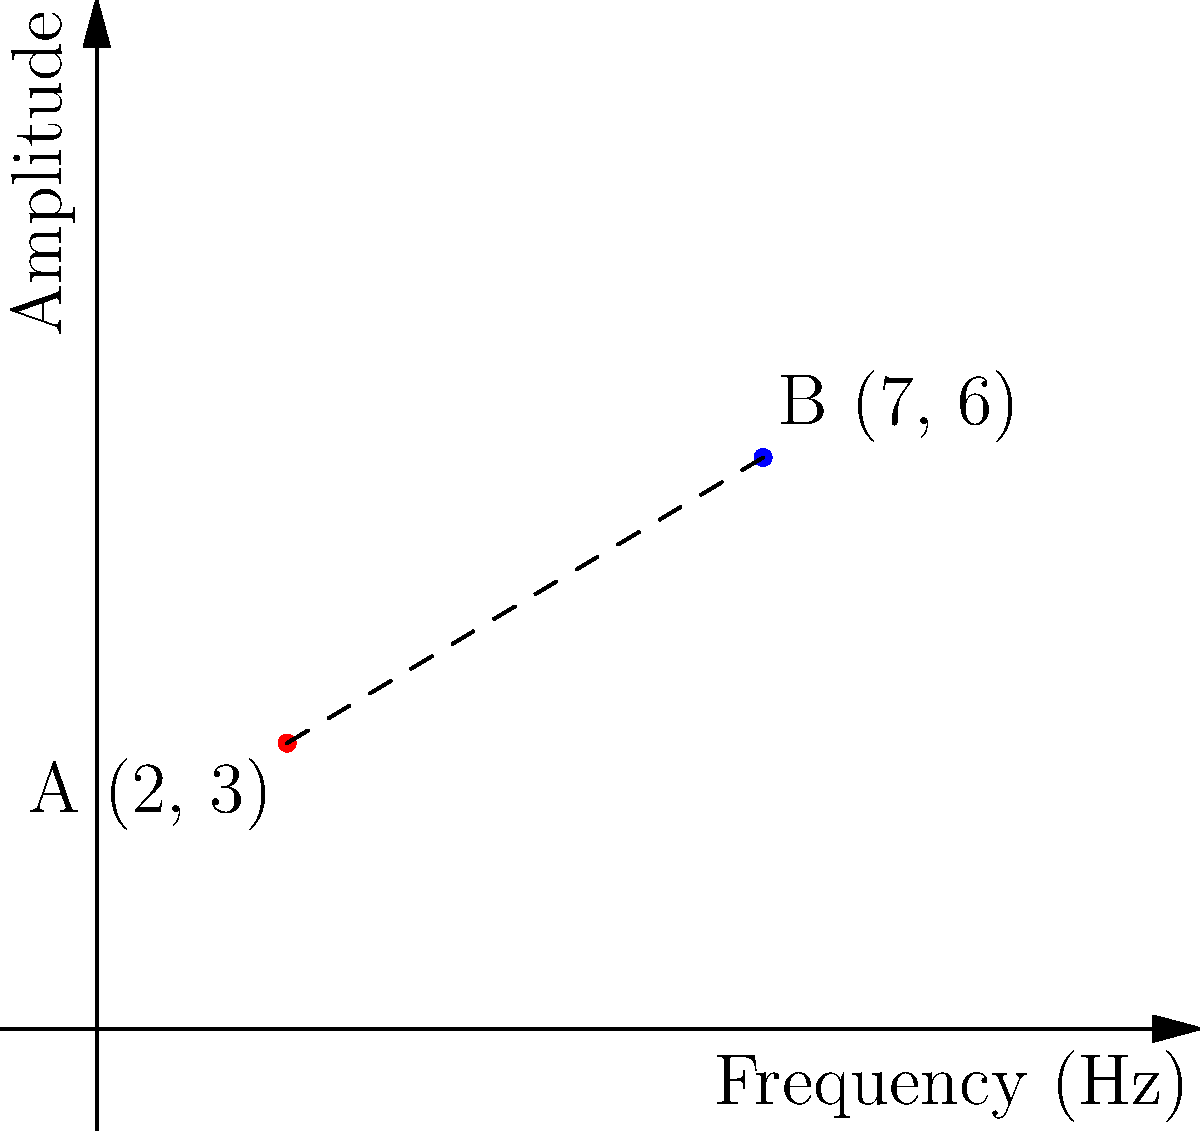In a musical composition, two notes are represented on a coordinate plane where the x-axis represents frequency (Hz) and the y-axis represents amplitude. Note A is located at (2, 3) and Note B is at (7, 6). Calculate the distance between these two musical notes on the plane, representing the tonal difference between them. Round your answer to two decimal places. To find the distance between two points on a coordinate plane, we use the distance formula:

$$d = \sqrt{(x_2 - x_1)^2 + (y_2 - y_1)^2}$$

Where $(x_1, y_1)$ represents the coordinates of the first point and $(x_2, y_2)$ represents the coordinates of the second point.

Given:
Point A (Note A): $(x_1, y_1) = (2, 3)$
Point B (Note B): $(x_2, y_2) = (7, 6)$

Let's substitute these values into the formula:

$$d = \sqrt{(7 - 2)^2 + (6 - 3)^2}$$

Now, let's solve step by step:

1) Simplify the expressions inside the parentheses:
   $$d = \sqrt{5^2 + 3^2}$$

2) Calculate the squares:
   $$d = \sqrt{25 + 9}$$

3) Add the numbers under the square root:
   $$d = \sqrt{34}$$

4) Calculate the square root and round to two decimal places:
   $$d \approx 5.83$$

Therefore, the distance between the two musical notes on the plane is approximately 5.83 units.
Answer: 5.83 units 